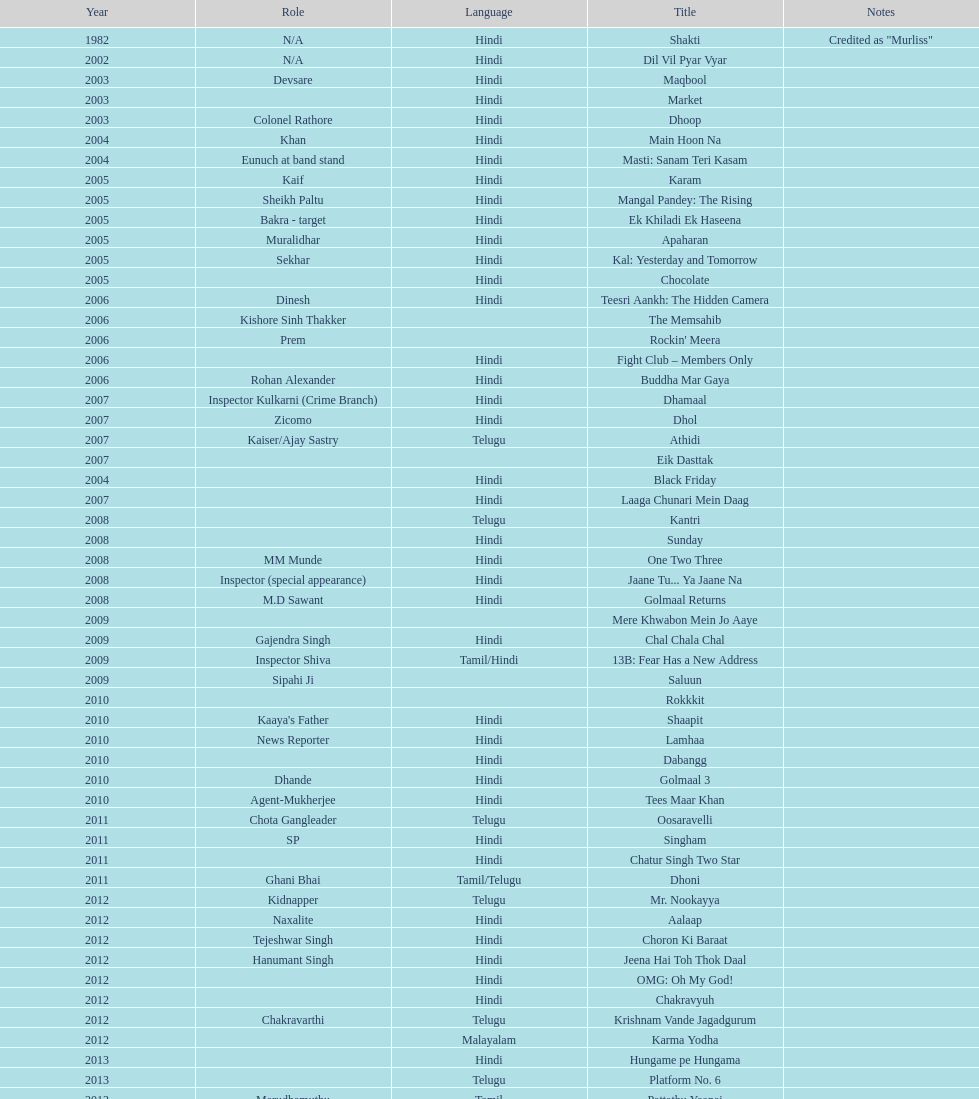Parse the full table. {'header': ['Year', 'Role', 'Language', 'Title', 'Notes'], 'rows': [['1982', 'N/A', 'Hindi', 'Shakti', 'Credited as "Murliss"'], ['2002', 'N/A', 'Hindi', 'Dil Vil Pyar Vyar', ''], ['2003', 'Devsare', 'Hindi', 'Maqbool', ''], ['2003', '', 'Hindi', 'Market', ''], ['2003', 'Colonel Rathore', 'Hindi', 'Dhoop', ''], ['2004', 'Khan', 'Hindi', 'Main Hoon Na', ''], ['2004', 'Eunuch at band stand', 'Hindi', 'Masti: Sanam Teri Kasam', ''], ['2005', 'Kaif', 'Hindi', 'Karam', ''], ['2005', 'Sheikh Paltu', 'Hindi', 'Mangal Pandey: The Rising', ''], ['2005', 'Bakra - target', 'Hindi', 'Ek Khiladi Ek Haseena', ''], ['2005', 'Muralidhar', 'Hindi', 'Apaharan', ''], ['2005', 'Sekhar', 'Hindi', 'Kal: Yesterday and Tomorrow', ''], ['2005', '', 'Hindi', 'Chocolate', ''], ['2006', 'Dinesh', 'Hindi', 'Teesri Aankh: The Hidden Camera', ''], ['2006', 'Kishore Sinh Thakker', '', 'The Memsahib', ''], ['2006', 'Prem', '', "Rockin' Meera", ''], ['2006', '', 'Hindi', 'Fight Club – Members Only', ''], ['2006', 'Rohan Alexander', 'Hindi', 'Buddha Mar Gaya', ''], ['2007', 'Inspector Kulkarni (Crime Branch)', 'Hindi', 'Dhamaal', ''], ['2007', 'Zicomo', 'Hindi', 'Dhol', ''], ['2007', 'Kaiser/Ajay Sastry', 'Telugu', 'Athidi', ''], ['2007', '', '', 'Eik Dasttak', ''], ['2004', '', 'Hindi', 'Black Friday', ''], ['2007', '', 'Hindi', 'Laaga Chunari Mein Daag', ''], ['2008', '', 'Telugu', 'Kantri', ''], ['2008', '', 'Hindi', 'Sunday', ''], ['2008', 'MM Munde', 'Hindi', 'One Two Three', ''], ['2008', 'Inspector (special appearance)', 'Hindi', 'Jaane Tu... Ya Jaane Na', ''], ['2008', 'M.D Sawant', 'Hindi', 'Golmaal Returns', ''], ['2009', '', '', 'Mere Khwabon Mein Jo Aaye', ''], ['2009', 'Gajendra Singh', 'Hindi', 'Chal Chala Chal', ''], ['2009', 'Inspector Shiva', 'Tamil/Hindi', '13B: Fear Has a New Address', ''], ['2009', 'Sipahi Ji', '', 'Saluun', ''], ['2010', '', '', 'Rokkkit', ''], ['2010', "Kaaya's Father", 'Hindi', 'Shaapit', ''], ['2010', 'News Reporter', 'Hindi', 'Lamhaa', ''], ['2010', '', 'Hindi', 'Dabangg', ''], ['2010', 'Dhande', 'Hindi', 'Golmaal 3', ''], ['2010', 'Agent-Mukherjee', 'Hindi', 'Tees Maar Khan', ''], ['2011', 'Chota Gangleader', 'Telugu', 'Oosaravelli', ''], ['2011', 'SP', 'Hindi', 'Singham', ''], ['2011', '', 'Hindi', 'Chatur Singh Two Star', ''], ['2011', 'Ghani Bhai', 'Tamil/Telugu', 'Dhoni', ''], ['2012', 'Kidnapper', 'Telugu', 'Mr. Nookayya', ''], ['2012', 'Naxalite', 'Hindi', 'Aalaap', ''], ['2012', 'Tejeshwar Singh', 'Hindi', 'Choron Ki Baraat', ''], ['2012', 'Hanumant Singh', 'Hindi', 'Jeena Hai Toh Thok Daal', ''], ['2012', '', 'Hindi', 'OMG: Oh My God!', ''], ['2012', '', 'Hindi', 'Chakravyuh', ''], ['2012', 'Chakravarthi', 'Telugu', 'Krishnam Vande Jagadgurum', ''], ['2012', '', 'Malayalam', 'Karma Yodha', ''], ['2013', '', 'Hindi', 'Hungame pe Hungama', ''], ['2013', '', 'Telugu', 'Platform No. 6', ''], ['2013', 'Marudhamuthu', 'Tamil', 'Pattathu Yaanai', ''], ['2013', '', 'Hindi', 'Zindagi 50-50', ''], ['2013', 'Durani', 'Telugu', 'Yevadu', ''], ['2013', '', 'Telugu', 'Karmachari', '']]} What is the total years on the chart 13. 